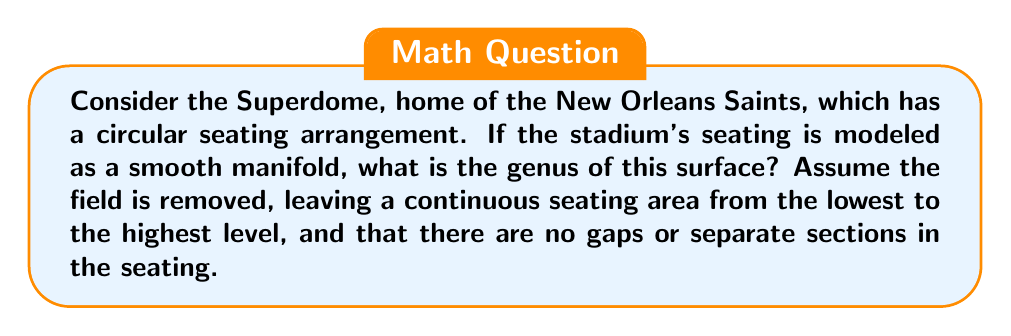Help me with this question. To determine the genus of the Superdome's seating arrangement, we need to analyze its topological properties:

1. The seating arrangement forms a circular shape when viewed from above.
2. The seating area rises from the lowest level to the highest level continuously.
3. There are no gaps or separate sections in the seating.

Given these characteristics, we can model the seating arrangement as a topological surface:

1. The surface is closed (has no boundary) because the seating forms a complete circle.
2. It is orientable, as we can consistently define an "inside" and "outside" of the surface.
3. The surface is connected, as there are no separate pieces.

Topologically, this surface is equivalent to a torus. We can visualize this by imagining the lowest level of seating as the inner circle of a donut, and the highest level as the outer circle. The continuous rise in seating connects these circles to form a torus-like shape.

The genus of a surface is defined as the maximum number of non-intersecting simple closed curves that can be drawn on the surface without separating it. For a torus, we can draw two such curves:
1. A curve around the "tube" of the torus
2. A curve through the center hole of the torus

Therefore, the genus of a torus is 1.

Mathematically, for a closed, orientable surface, the genus $g$ is related to the Euler characteristic $\chi$ by the formula:

$$\chi = 2 - 2g$$

For a torus, $\chi = 0$, so:

$$0 = 2 - 2g$$
$$2g = 2$$
$$g = 1$$

This confirms our topological analysis that the genus is 1.
Answer: The genus of the Superdome's seating arrangement, modeled as a smooth manifold, is 1. 